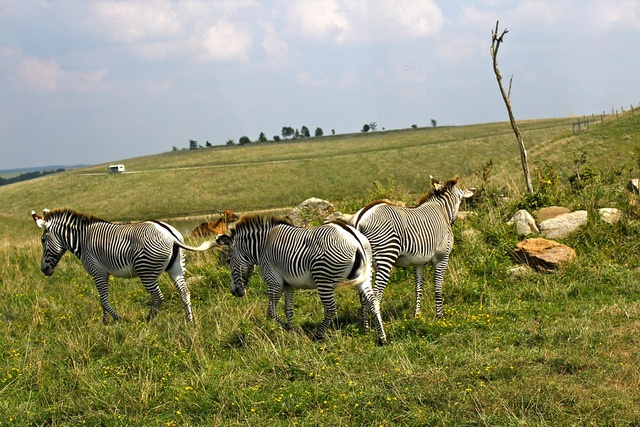Describe the objects in this image and their specific colors. I can see zebra in lightgray, black, gray, darkgreen, and ivory tones, zebra in lightgray, black, gray, darkgreen, and ivory tones, zebra in lightgray, olive, black, ivory, and tan tones, and truck in lightgray, beige, gray, black, and olive tones in this image. 